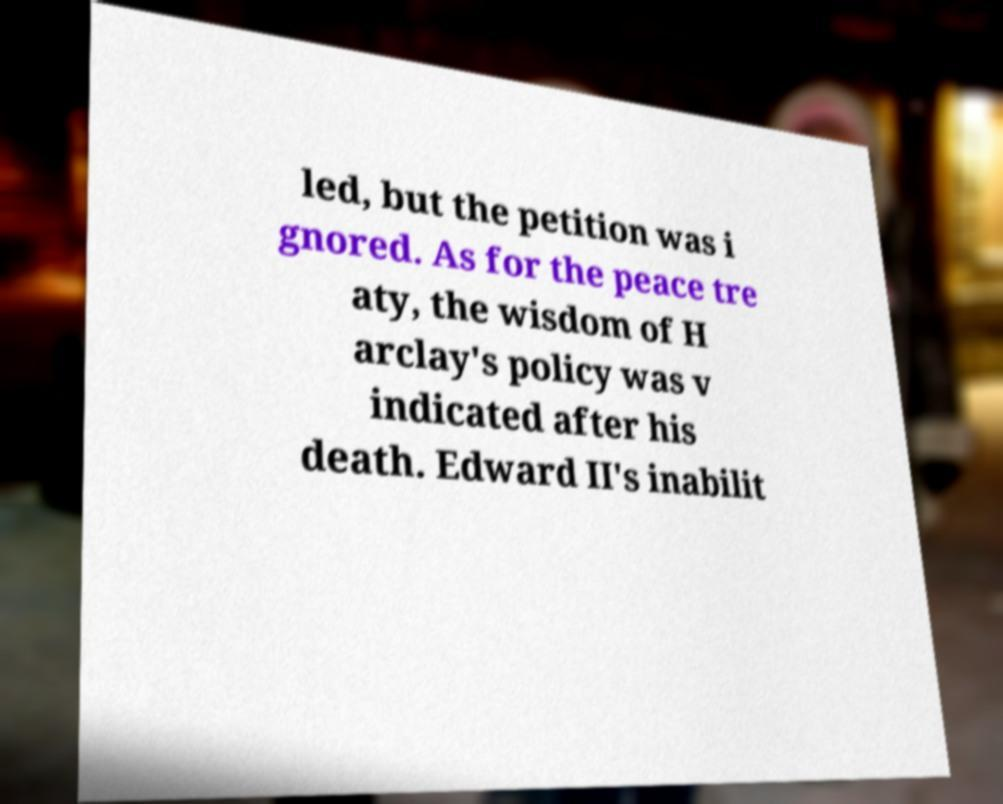There's text embedded in this image that I need extracted. Can you transcribe it verbatim? led, but the petition was i gnored. As for the peace tre aty, the wisdom of H arclay's policy was v indicated after his death. Edward II's inabilit 